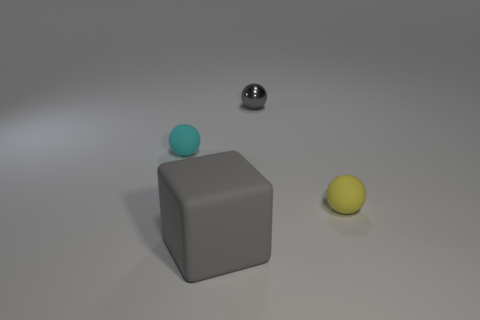Is the cube the same color as the metallic thing?
Provide a succinct answer. Yes. Is the material of the large cube the same as the tiny gray thing left of the yellow matte object?
Provide a short and direct response. No. What number of tiny balls are behind the cyan matte object and in front of the small cyan object?
Your answer should be compact. 0. What shape is the cyan rubber thing that is the same size as the yellow matte object?
Provide a succinct answer. Sphere. Are there any small yellow rubber balls that are in front of the small rubber thing right of the ball that is to the left of the gray metallic sphere?
Offer a very short reply. No. Does the metallic sphere have the same color as the tiny thing in front of the cyan rubber object?
Offer a very short reply. No. What number of metal objects are the same color as the matte block?
Your answer should be very brief. 1. There is a rubber sphere in front of the small matte thing left of the gray sphere; what size is it?
Your response must be concise. Small. How many objects are either gray things right of the big cube or large green metal spheres?
Your response must be concise. 1. Are there any gray rubber things of the same size as the gray block?
Provide a short and direct response. No. 